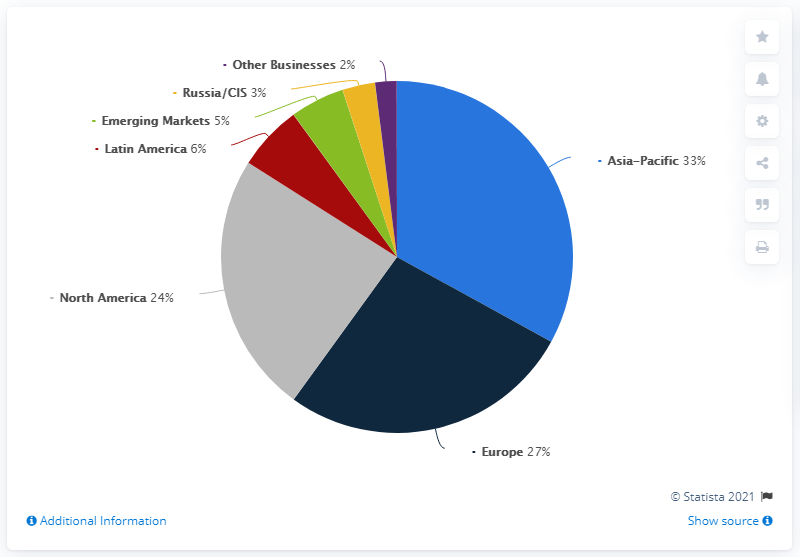Draw attention to some important aspects in this diagram. The total distribution of Adidas retail net sales in 2020 for the Europe and Asia-Pacific regions was approximately 60%. Adidas retail net sales in Europe in 2020 were approximately 27%. 